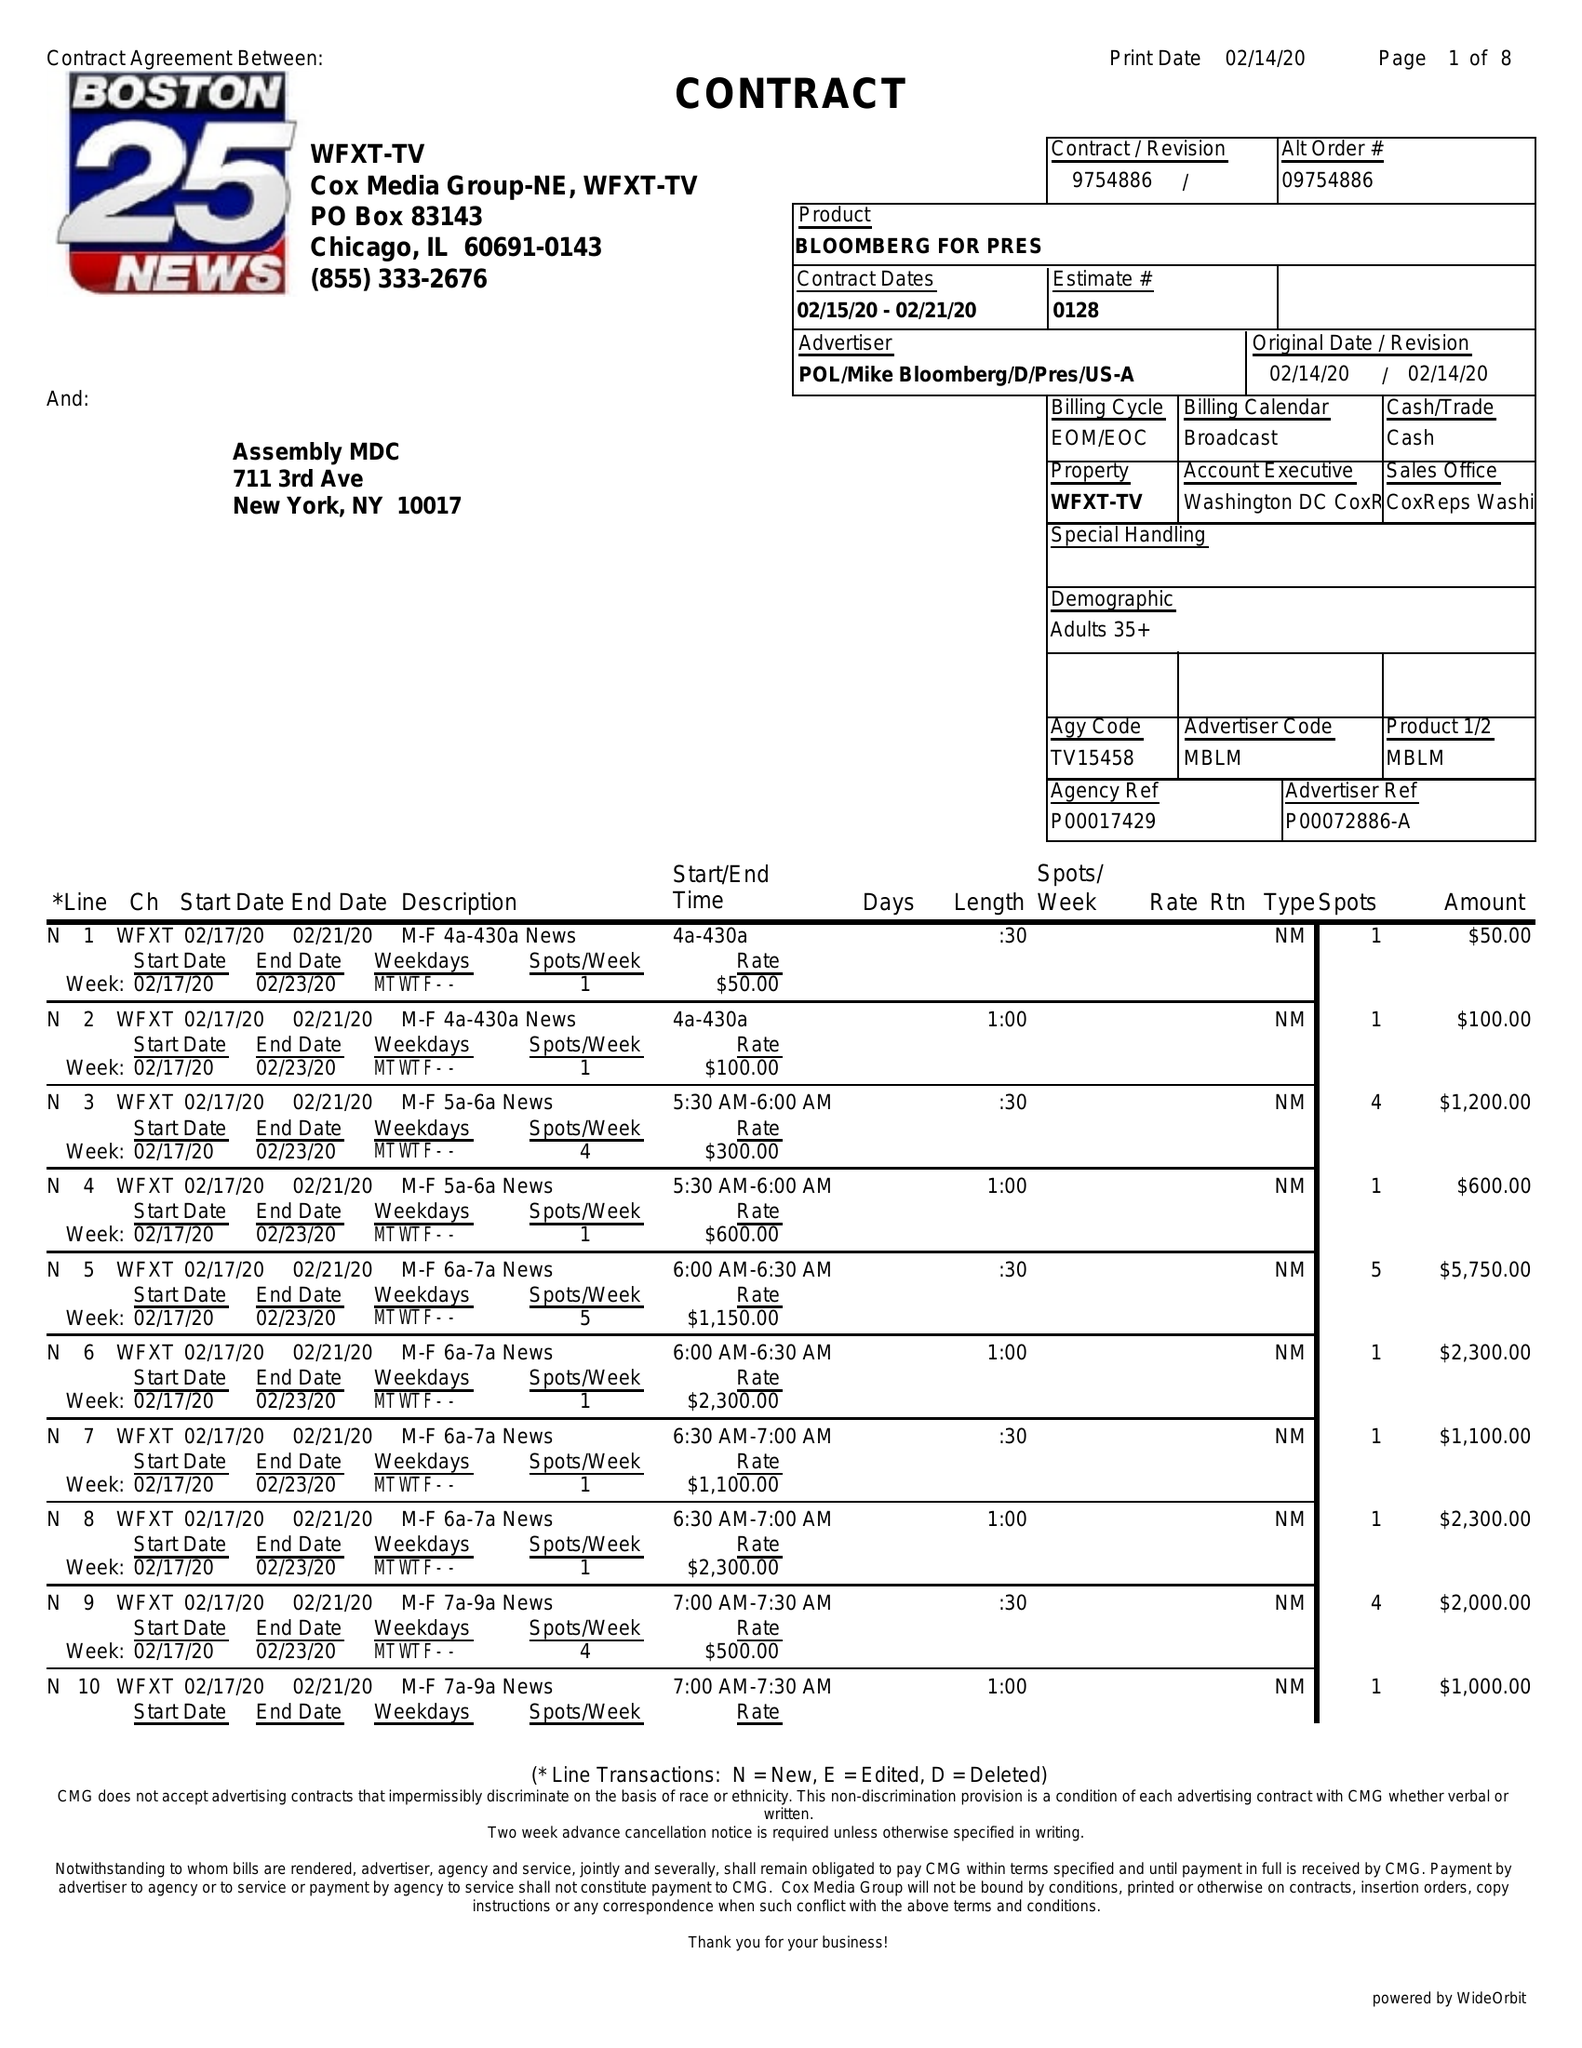What is the value for the flight_to?
Answer the question using a single word or phrase. 02/21/20 